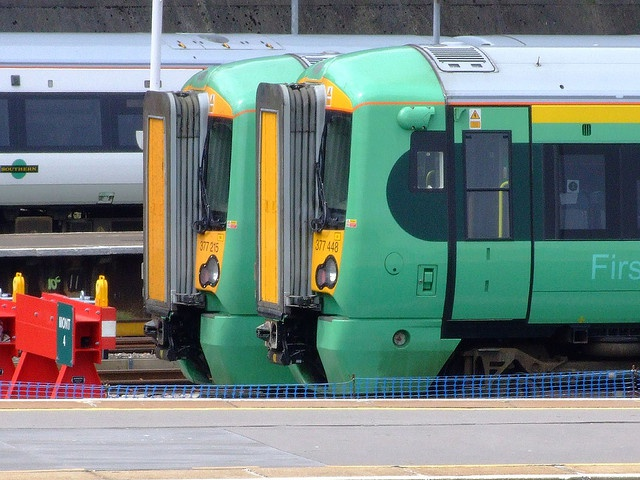Describe the objects in this image and their specific colors. I can see train in black, turquoise, and teal tones, train in black, lavender, lightblue, and darkblue tones, and train in black, gray, turquoise, and teal tones in this image. 